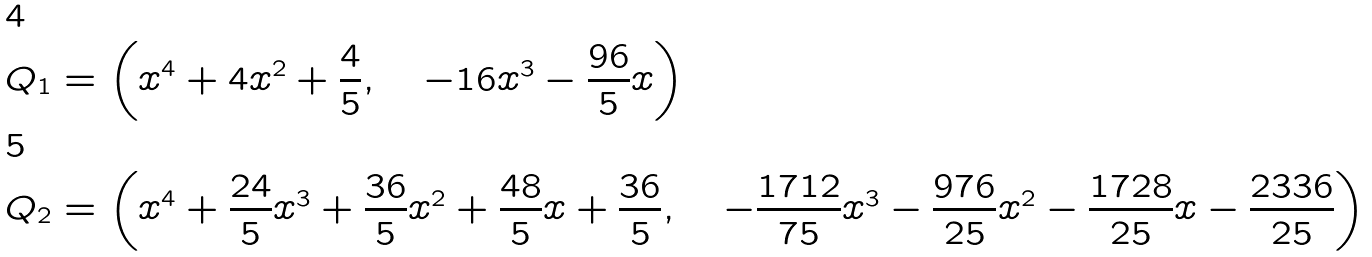<formula> <loc_0><loc_0><loc_500><loc_500>Q _ { 1 } & = \left ( x ^ { 4 } + 4 x ^ { 2 } + \frac { 4 } { 5 } , \quad - 1 6 x ^ { 3 } - \frac { 9 6 } { 5 } x \right ) \\ Q _ { 2 } & = \left ( x ^ { 4 } + \frac { 2 4 } { 5 } x ^ { 3 } + \frac { 3 6 } { 5 } x ^ { 2 } + \frac { 4 8 } { 5 } x + \frac { 3 6 } { 5 } , \quad - \frac { 1 7 1 2 } { 7 5 } x ^ { 3 } - \frac { 9 7 6 } { 2 5 } x ^ { 2 } - \frac { 1 7 2 8 } { 2 5 } x - \frac { 2 3 3 6 } { 2 5 } \right )</formula> 